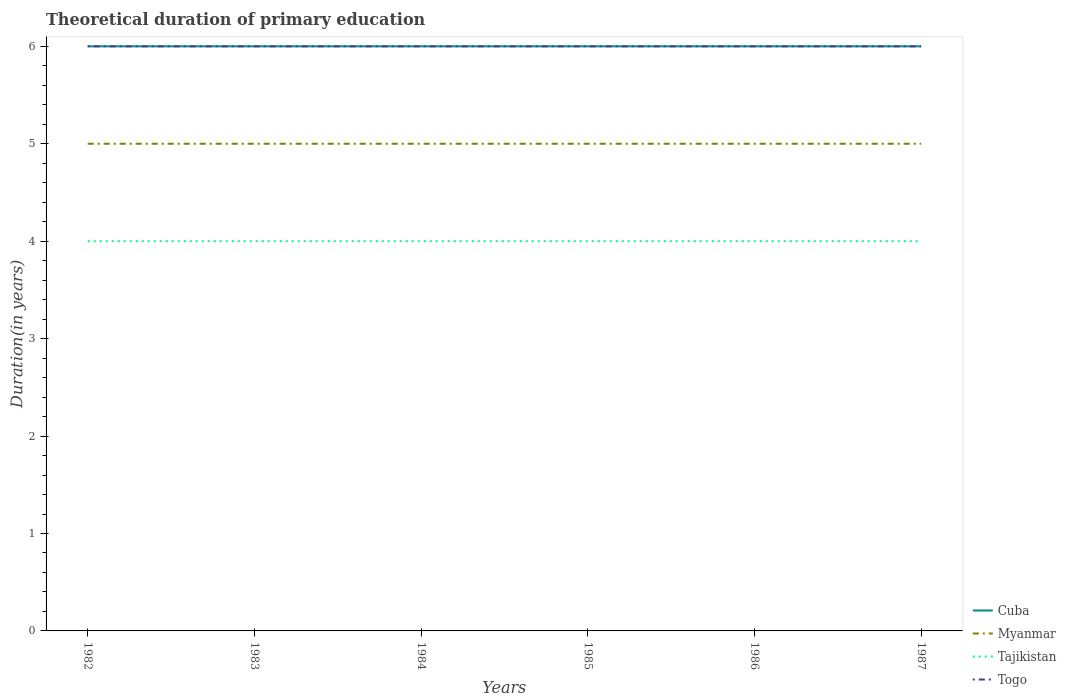Does the line corresponding to Myanmar intersect with the line corresponding to Togo?
Offer a terse response. No. Is the number of lines equal to the number of legend labels?
Your response must be concise. Yes. Across all years, what is the maximum total theoretical duration of primary education in Tajikistan?
Your answer should be compact. 4. In which year was the total theoretical duration of primary education in Togo maximum?
Give a very brief answer. 1982. What is the total total theoretical duration of primary education in Myanmar in the graph?
Make the answer very short. 0. What is the difference between the highest and the second highest total theoretical duration of primary education in Togo?
Give a very brief answer. 0. What is the difference between the highest and the lowest total theoretical duration of primary education in Tajikistan?
Offer a terse response. 0. Is the total theoretical duration of primary education in Cuba strictly greater than the total theoretical duration of primary education in Myanmar over the years?
Offer a very short reply. No. How many lines are there?
Ensure brevity in your answer.  4. How many years are there in the graph?
Keep it short and to the point. 6. What is the difference between two consecutive major ticks on the Y-axis?
Your answer should be compact. 1. Are the values on the major ticks of Y-axis written in scientific E-notation?
Offer a very short reply. No. Does the graph contain grids?
Provide a short and direct response. No. Where does the legend appear in the graph?
Your response must be concise. Bottom right. How are the legend labels stacked?
Give a very brief answer. Vertical. What is the title of the graph?
Your answer should be very brief. Theoretical duration of primary education. What is the label or title of the X-axis?
Provide a succinct answer. Years. What is the label or title of the Y-axis?
Your response must be concise. Duration(in years). What is the Duration(in years) of Cuba in 1982?
Keep it short and to the point. 6. What is the Duration(in years) of Tajikistan in 1982?
Provide a short and direct response. 4. What is the Duration(in years) in Cuba in 1983?
Your answer should be very brief. 6. What is the Duration(in years) of Togo in 1983?
Your answer should be compact. 6. What is the Duration(in years) in Cuba in 1984?
Give a very brief answer. 6. What is the Duration(in years) of Cuba in 1985?
Make the answer very short. 6. What is the Duration(in years) in Tajikistan in 1985?
Give a very brief answer. 4. What is the Duration(in years) of Togo in 1985?
Provide a short and direct response. 6. What is the Duration(in years) in Cuba in 1986?
Make the answer very short. 6. What is the Duration(in years) in Tajikistan in 1986?
Make the answer very short. 4. What is the Duration(in years) of Togo in 1986?
Give a very brief answer. 6. What is the Duration(in years) of Cuba in 1987?
Your answer should be very brief. 6. What is the Duration(in years) in Togo in 1987?
Your response must be concise. 6. Across all years, what is the maximum Duration(in years) of Cuba?
Offer a very short reply. 6. Across all years, what is the minimum Duration(in years) in Cuba?
Ensure brevity in your answer.  6. Across all years, what is the minimum Duration(in years) in Tajikistan?
Give a very brief answer. 4. What is the total Duration(in years) of Cuba in the graph?
Your response must be concise. 36. What is the total Duration(in years) of Myanmar in the graph?
Offer a very short reply. 30. What is the total Duration(in years) of Tajikistan in the graph?
Provide a short and direct response. 24. What is the difference between the Duration(in years) in Tajikistan in 1982 and that in 1983?
Provide a succinct answer. 0. What is the difference between the Duration(in years) in Togo in 1982 and that in 1983?
Your answer should be very brief. 0. What is the difference between the Duration(in years) of Cuba in 1982 and that in 1984?
Offer a very short reply. 0. What is the difference between the Duration(in years) in Tajikistan in 1982 and that in 1985?
Provide a succinct answer. 0. What is the difference between the Duration(in years) of Togo in 1982 and that in 1985?
Your answer should be compact. 0. What is the difference between the Duration(in years) of Myanmar in 1982 and that in 1986?
Your answer should be compact. 0. What is the difference between the Duration(in years) in Tajikistan in 1982 and that in 1986?
Your response must be concise. 0. What is the difference between the Duration(in years) in Togo in 1982 and that in 1986?
Provide a succinct answer. 0. What is the difference between the Duration(in years) in Cuba in 1982 and that in 1987?
Your answer should be very brief. 0. What is the difference between the Duration(in years) of Tajikistan in 1982 and that in 1987?
Your answer should be compact. 0. What is the difference between the Duration(in years) in Myanmar in 1983 and that in 1984?
Provide a short and direct response. 0. What is the difference between the Duration(in years) in Myanmar in 1983 and that in 1985?
Your response must be concise. 0. What is the difference between the Duration(in years) in Tajikistan in 1983 and that in 1985?
Provide a short and direct response. 0. What is the difference between the Duration(in years) of Togo in 1983 and that in 1985?
Make the answer very short. 0. What is the difference between the Duration(in years) of Tajikistan in 1983 and that in 1986?
Ensure brevity in your answer.  0. What is the difference between the Duration(in years) in Togo in 1983 and that in 1986?
Offer a very short reply. 0. What is the difference between the Duration(in years) in Myanmar in 1983 and that in 1987?
Offer a terse response. 0. What is the difference between the Duration(in years) in Togo in 1983 and that in 1987?
Your answer should be compact. 0. What is the difference between the Duration(in years) of Tajikistan in 1984 and that in 1985?
Provide a succinct answer. 0. What is the difference between the Duration(in years) of Cuba in 1984 and that in 1986?
Your answer should be very brief. 0. What is the difference between the Duration(in years) in Myanmar in 1984 and that in 1986?
Ensure brevity in your answer.  0. What is the difference between the Duration(in years) in Cuba in 1984 and that in 1987?
Offer a very short reply. 0. What is the difference between the Duration(in years) in Myanmar in 1984 and that in 1987?
Provide a succinct answer. 0. What is the difference between the Duration(in years) of Cuba in 1985 and that in 1986?
Provide a succinct answer. 0. What is the difference between the Duration(in years) in Myanmar in 1985 and that in 1986?
Give a very brief answer. 0. What is the difference between the Duration(in years) of Tajikistan in 1985 and that in 1987?
Make the answer very short. 0. What is the difference between the Duration(in years) in Cuba in 1986 and that in 1987?
Make the answer very short. 0. What is the difference between the Duration(in years) in Tajikistan in 1986 and that in 1987?
Your answer should be very brief. 0. What is the difference between the Duration(in years) in Cuba in 1982 and the Duration(in years) in Tajikistan in 1983?
Offer a very short reply. 2. What is the difference between the Duration(in years) of Cuba in 1982 and the Duration(in years) of Togo in 1983?
Make the answer very short. 0. What is the difference between the Duration(in years) in Myanmar in 1982 and the Duration(in years) in Togo in 1983?
Provide a succinct answer. -1. What is the difference between the Duration(in years) of Cuba in 1982 and the Duration(in years) of Myanmar in 1984?
Provide a succinct answer. 1. What is the difference between the Duration(in years) of Cuba in 1982 and the Duration(in years) of Tajikistan in 1984?
Ensure brevity in your answer.  2. What is the difference between the Duration(in years) in Cuba in 1982 and the Duration(in years) in Togo in 1984?
Make the answer very short. 0. What is the difference between the Duration(in years) in Myanmar in 1982 and the Duration(in years) in Tajikistan in 1984?
Offer a terse response. 1. What is the difference between the Duration(in years) in Tajikistan in 1982 and the Duration(in years) in Togo in 1984?
Your response must be concise. -2. What is the difference between the Duration(in years) of Myanmar in 1982 and the Duration(in years) of Tajikistan in 1985?
Give a very brief answer. 1. What is the difference between the Duration(in years) of Myanmar in 1982 and the Duration(in years) of Togo in 1985?
Ensure brevity in your answer.  -1. What is the difference between the Duration(in years) of Cuba in 1982 and the Duration(in years) of Myanmar in 1986?
Your answer should be very brief. 1. What is the difference between the Duration(in years) of Myanmar in 1982 and the Duration(in years) of Tajikistan in 1986?
Your response must be concise. 1. What is the difference between the Duration(in years) of Cuba in 1982 and the Duration(in years) of Myanmar in 1987?
Give a very brief answer. 1. What is the difference between the Duration(in years) of Cuba in 1982 and the Duration(in years) of Togo in 1987?
Make the answer very short. 0. What is the difference between the Duration(in years) in Myanmar in 1982 and the Duration(in years) in Togo in 1987?
Offer a very short reply. -1. What is the difference between the Duration(in years) of Cuba in 1983 and the Duration(in years) of Myanmar in 1984?
Provide a short and direct response. 1. What is the difference between the Duration(in years) in Cuba in 1983 and the Duration(in years) in Tajikistan in 1984?
Provide a short and direct response. 2. What is the difference between the Duration(in years) of Myanmar in 1983 and the Duration(in years) of Tajikistan in 1984?
Offer a very short reply. 1. What is the difference between the Duration(in years) of Cuba in 1983 and the Duration(in years) of Myanmar in 1985?
Provide a succinct answer. 1. What is the difference between the Duration(in years) in Cuba in 1983 and the Duration(in years) in Tajikistan in 1985?
Ensure brevity in your answer.  2. What is the difference between the Duration(in years) in Tajikistan in 1983 and the Duration(in years) in Togo in 1985?
Your answer should be very brief. -2. What is the difference between the Duration(in years) of Cuba in 1983 and the Duration(in years) of Myanmar in 1986?
Provide a short and direct response. 1. What is the difference between the Duration(in years) in Cuba in 1983 and the Duration(in years) in Togo in 1986?
Provide a short and direct response. 0. What is the difference between the Duration(in years) of Myanmar in 1983 and the Duration(in years) of Togo in 1986?
Provide a short and direct response. -1. What is the difference between the Duration(in years) of Tajikistan in 1983 and the Duration(in years) of Togo in 1986?
Your answer should be very brief. -2. What is the difference between the Duration(in years) in Cuba in 1983 and the Duration(in years) in Myanmar in 1987?
Give a very brief answer. 1. What is the difference between the Duration(in years) in Myanmar in 1983 and the Duration(in years) in Tajikistan in 1987?
Keep it short and to the point. 1. What is the difference between the Duration(in years) in Cuba in 1984 and the Duration(in years) in Myanmar in 1985?
Provide a succinct answer. 1. What is the difference between the Duration(in years) in Tajikistan in 1984 and the Duration(in years) in Togo in 1985?
Your answer should be compact. -2. What is the difference between the Duration(in years) in Cuba in 1984 and the Duration(in years) in Tajikistan in 1986?
Keep it short and to the point. 2. What is the difference between the Duration(in years) of Myanmar in 1984 and the Duration(in years) of Tajikistan in 1986?
Provide a short and direct response. 1. What is the difference between the Duration(in years) of Myanmar in 1984 and the Duration(in years) of Togo in 1986?
Give a very brief answer. -1. What is the difference between the Duration(in years) of Cuba in 1984 and the Duration(in years) of Myanmar in 1987?
Provide a short and direct response. 1. What is the difference between the Duration(in years) in Cuba in 1984 and the Duration(in years) in Tajikistan in 1987?
Ensure brevity in your answer.  2. What is the difference between the Duration(in years) in Myanmar in 1984 and the Duration(in years) in Tajikistan in 1987?
Offer a terse response. 1. What is the difference between the Duration(in years) of Tajikistan in 1984 and the Duration(in years) of Togo in 1987?
Ensure brevity in your answer.  -2. What is the difference between the Duration(in years) of Cuba in 1985 and the Duration(in years) of Myanmar in 1986?
Your answer should be very brief. 1. What is the difference between the Duration(in years) of Cuba in 1985 and the Duration(in years) of Tajikistan in 1986?
Your response must be concise. 2. What is the difference between the Duration(in years) in Myanmar in 1985 and the Duration(in years) in Togo in 1986?
Your response must be concise. -1. What is the difference between the Duration(in years) in Tajikistan in 1985 and the Duration(in years) in Togo in 1986?
Offer a terse response. -2. What is the difference between the Duration(in years) in Cuba in 1985 and the Duration(in years) in Myanmar in 1987?
Your response must be concise. 1. What is the difference between the Duration(in years) of Myanmar in 1985 and the Duration(in years) of Tajikistan in 1987?
Give a very brief answer. 1. What is the difference between the Duration(in years) of Cuba in 1986 and the Duration(in years) of Myanmar in 1987?
Give a very brief answer. 1. What is the difference between the Duration(in years) of Cuba in 1986 and the Duration(in years) of Tajikistan in 1987?
Provide a succinct answer. 2. What is the difference between the Duration(in years) of Myanmar in 1986 and the Duration(in years) of Tajikistan in 1987?
Provide a succinct answer. 1. What is the difference between the Duration(in years) in Myanmar in 1986 and the Duration(in years) in Togo in 1987?
Offer a terse response. -1. What is the average Duration(in years) in Cuba per year?
Provide a succinct answer. 6. What is the average Duration(in years) in Myanmar per year?
Provide a short and direct response. 5. In the year 1982, what is the difference between the Duration(in years) of Cuba and Duration(in years) of Myanmar?
Your answer should be very brief. 1. In the year 1982, what is the difference between the Duration(in years) of Cuba and Duration(in years) of Tajikistan?
Provide a succinct answer. 2. In the year 1982, what is the difference between the Duration(in years) of Cuba and Duration(in years) of Togo?
Make the answer very short. 0. In the year 1982, what is the difference between the Duration(in years) of Tajikistan and Duration(in years) of Togo?
Provide a succinct answer. -2. In the year 1983, what is the difference between the Duration(in years) of Cuba and Duration(in years) of Myanmar?
Your answer should be very brief. 1. In the year 1983, what is the difference between the Duration(in years) of Cuba and Duration(in years) of Tajikistan?
Give a very brief answer. 2. In the year 1983, what is the difference between the Duration(in years) in Cuba and Duration(in years) in Togo?
Your answer should be compact. 0. In the year 1983, what is the difference between the Duration(in years) of Myanmar and Duration(in years) of Togo?
Make the answer very short. -1. In the year 1983, what is the difference between the Duration(in years) in Tajikistan and Duration(in years) in Togo?
Your answer should be very brief. -2. In the year 1984, what is the difference between the Duration(in years) of Cuba and Duration(in years) of Tajikistan?
Offer a terse response. 2. In the year 1984, what is the difference between the Duration(in years) of Myanmar and Duration(in years) of Togo?
Keep it short and to the point. -1. In the year 1984, what is the difference between the Duration(in years) of Tajikistan and Duration(in years) of Togo?
Ensure brevity in your answer.  -2. In the year 1985, what is the difference between the Duration(in years) in Cuba and Duration(in years) in Togo?
Your answer should be very brief. 0. In the year 1985, what is the difference between the Duration(in years) of Myanmar and Duration(in years) of Tajikistan?
Your answer should be compact. 1. In the year 1985, what is the difference between the Duration(in years) in Myanmar and Duration(in years) in Togo?
Give a very brief answer. -1. In the year 1985, what is the difference between the Duration(in years) in Tajikistan and Duration(in years) in Togo?
Offer a terse response. -2. In the year 1986, what is the difference between the Duration(in years) of Cuba and Duration(in years) of Myanmar?
Offer a very short reply. 1. In the year 1986, what is the difference between the Duration(in years) in Cuba and Duration(in years) in Tajikistan?
Your answer should be compact. 2. In the year 1986, what is the difference between the Duration(in years) of Cuba and Duration(in years) of Togo?
Keep it short and to the point. 0. In the year 1986, what is the difference between the Duration(in years) of Myanmar and Duration(in years) of Togo?
Offer a terse response. -1. In the year 1986, what is the difference between the Duration(in years) of Tajikistan and Duration(in years) of Togo?
Your response must be concise. -2. In the year 1987, what is the difference between the Duration(in years) of Cuba and Duration(in years) of Myanmar?
Offer a very short reply. 1. In the year 1987, what is the difference between the Duration(in years) in Cuba and Duration(in years) in Togo?
Your answer should be very brief. 0. In the year 1987, what is the difference between the Duration(in years) in Myanmar and Duration(in years) in Togo?
Provide a succinct answer. -1. In the year 1987, what is the difference between the Duration(in years) of Tajikistan and Duration(in years) of Togo?
Your answer should be compact. -2. What is the ratio of the Duration(in years) in Myanmar in 1982 to that in 1983?
Keep it short and to the point. 1. What is the ratio of the Duration(in years) in Togo in 1982 to that in 1983?
Your response must be concise. 1. What is the ratio of the Duration(in years) of Tajikistan in 1982 to that in 1984?
Offer a very short reply. 1. What is the ratio of the Duration(in years) of Togo in 1982 to that in 1984?
Your answer should be compact. 1. What is the ratio of the Duration(in years) in Myanmar in 1982 to that in 1985?
Provide a short and direct response. 1. What is the ratio of the Duration(in years) of Tajikistan in 1982 to that in 1985?
Provide a succinct answer. 1. What is the ratio of the Duration(in years) in Tajikistan in 1983 to that in 1984?
Ensure brevity in your answer.  1. What is the ratio of the Duration(in years) of Tajikistan in 1983 to that in 1985?
Your answer should be compact. 1. What is the ratio of the Duration(in years) of Myanmar in 1983 to that in 1986?
Your answer should be compact. 1. What is the ratio of the Duration(in years) of Togo in 1983 to that in 1986?
Give a very brief answer. 1. What is the ratio of the Duration(in years) in Tajikistan in 1983 to that in 1987?
Make the answer very short. 1. What is the ratio of the Duration(in years) of Togo in 1983 to that in 1987?
Provide a short and direct response. 1. What is the ratio of the Duration(in years) in Cuba in 1984 to that in 1985?
Offer a very short reply. 1. What is the ratio of the Duration(in years) in Tajikistan in 1984 to that in 1985?
Give a very brief answer. 1. What is the ratio of the Duration(in years) in Togo in 1984 to that in 1985?
Keep it short and to the point. 1. What is the ratio of the Duration(in years) in Tajikistan in 1984 to that in 1986?
Make the answer very short. 1. What is the ratio of the Duration(in years) of Togo in 1984 to that in 1986?
Give a very brief answer. 1. What is the ratio of the Duration(in years) in Tajikistan in 1984 to that in 1987?
Make the answer very short. 1. What is the ratio of the Duration(in years) of Togo in 1984 to that in 1987?
Your answer should be compact. 1. What is the ratio of the Duration(in years) of Myanmar in 1985 to that in 1986?
Your response must be concise. 1. What is the ratio of the Duration(in years) in Cuba in 1986 to that in 1987?
Your answer should be compact. 1. What is the ratio of the Duration(in years) in Togo in 1986 to that in 1987?
Offer a terse response. 1. What is the difference between the highest and the second highest Duration(in years) in Cuba?
Ensure brevity in your answer.  0. What is the difference between the highest and the second highest Duration(in years) of Tajikistan?
Ensure brevity in your answer.  0. What is the difference between the highest and the second highest Duration(in years) of Togo?
Provide a short and direct response. 0. What is the difference between the highest and the lowest Duration(in years) of Cuba?
Provide a short and direct response. 0. What is the difference between the highest and the lowest Duration(in years) of Myanmar?
Provide a short and direct response. 0. 